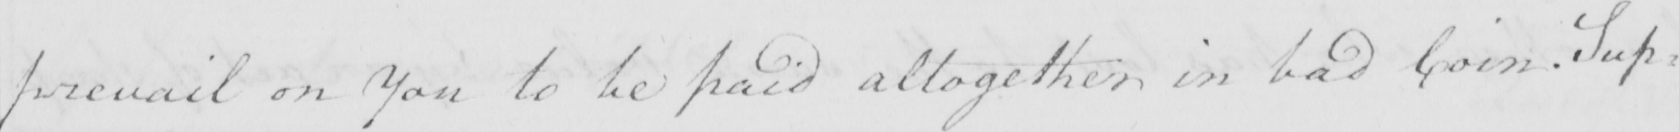What does this handwritten line say? prevail on You to be paid altogether in bad Coin . Sup= 